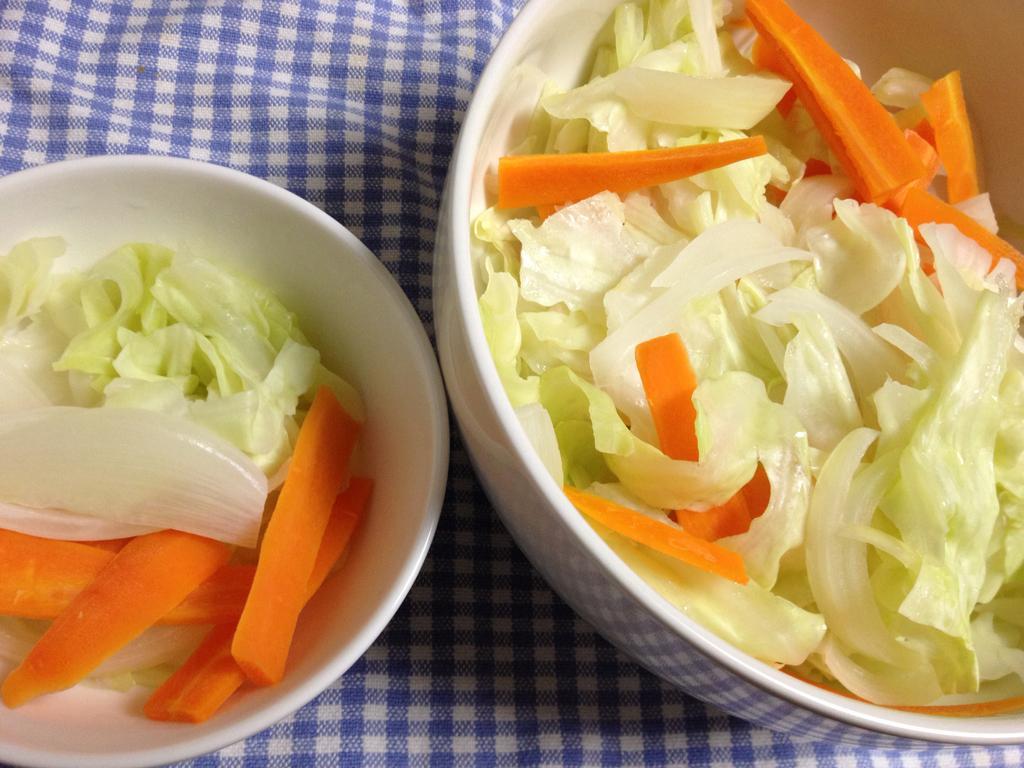In one or two sentences, can you explain what this image depicts? In this picture we can see food in the bowls, and also we can see a napkin. 